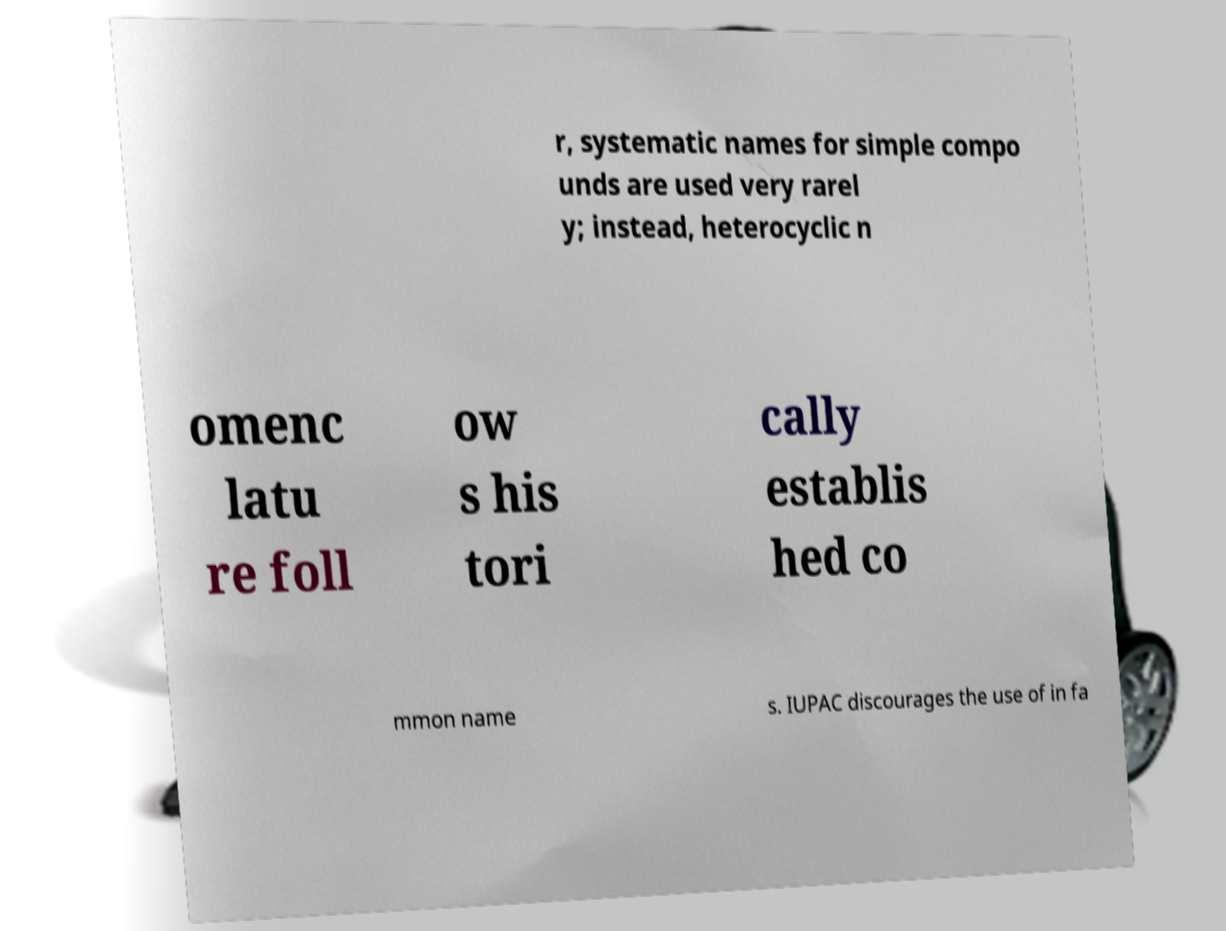I need the written content from this picture converted into text. Can you do that? r, systematic names for simple compo unds are used very rarel y; instead, heterocyclic n omenc latu re foll ow s his tori cally establis hed co mmon name s. IUPAC discourages the use of in fa 